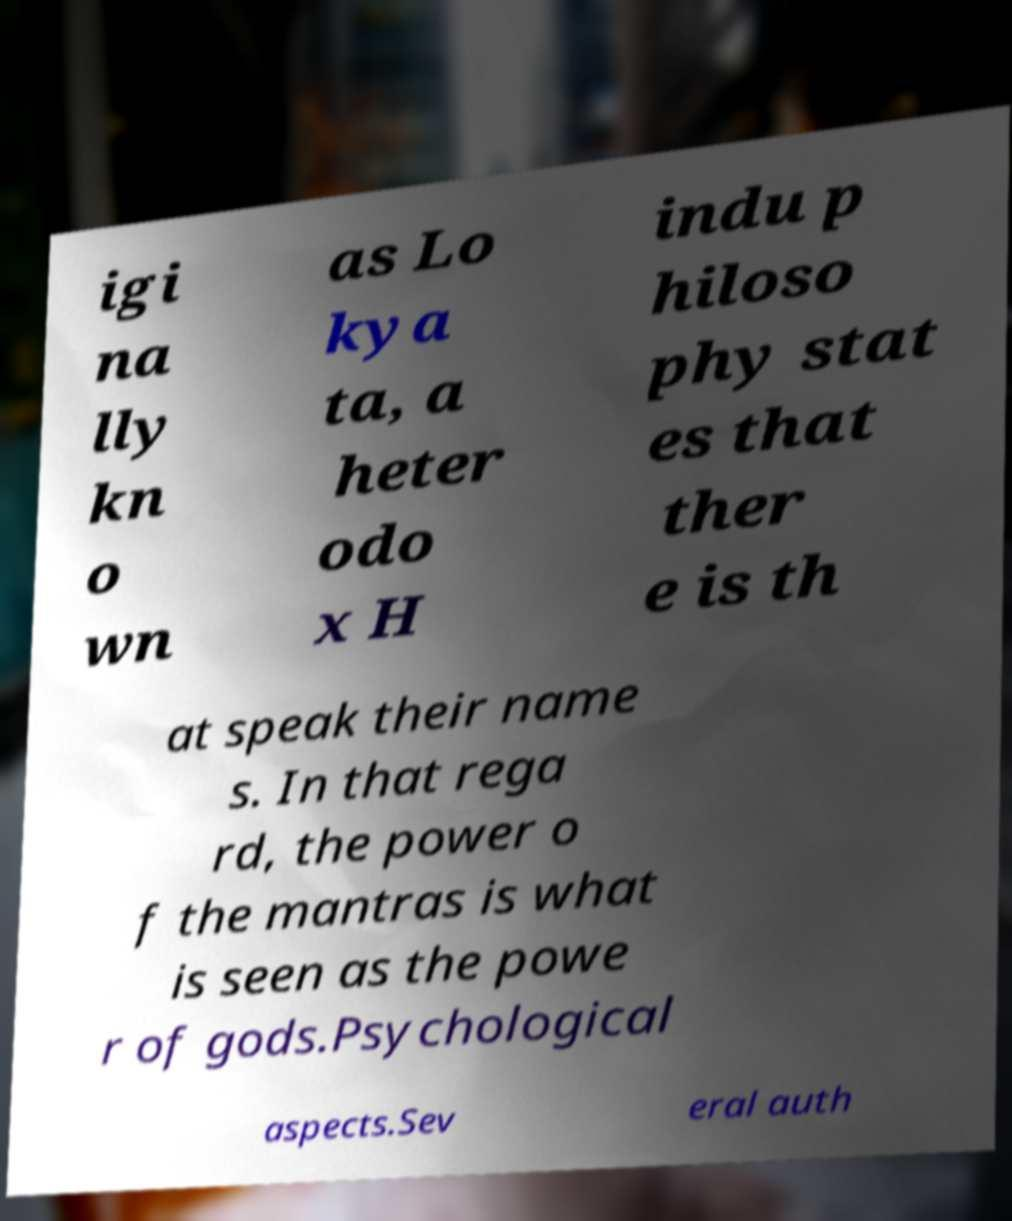Can you accurately transcribe the text from the provided image for me? igi na lly kn o wn as Lo kya ta, a heter odo x H indu p hiloso phy stat es that ther e is th at speak their name s. In that rega rd, the power o f the mantras is what is seen as the powe r of gods.Psychological aspects.Sev eral auth 